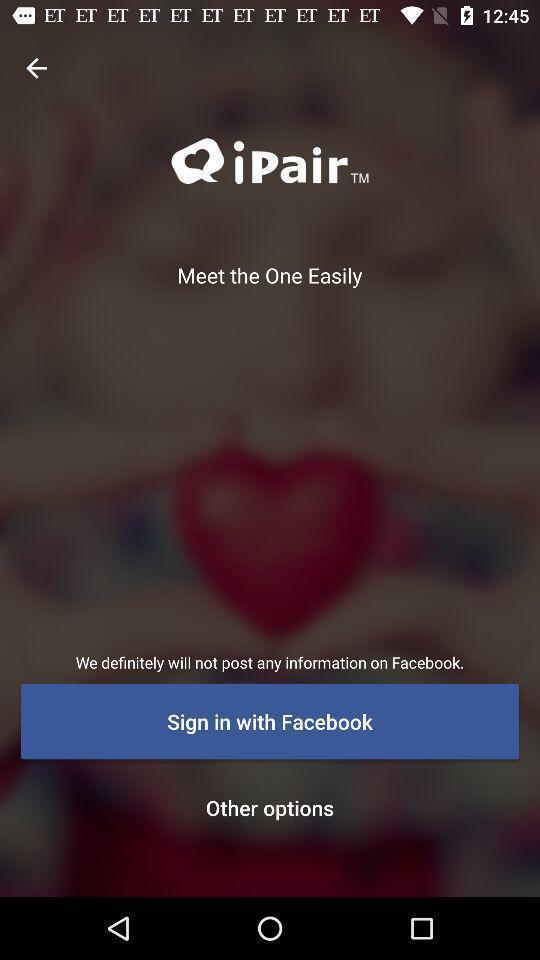Give me a summary of this screen capture. Welcome to the sign in page. 